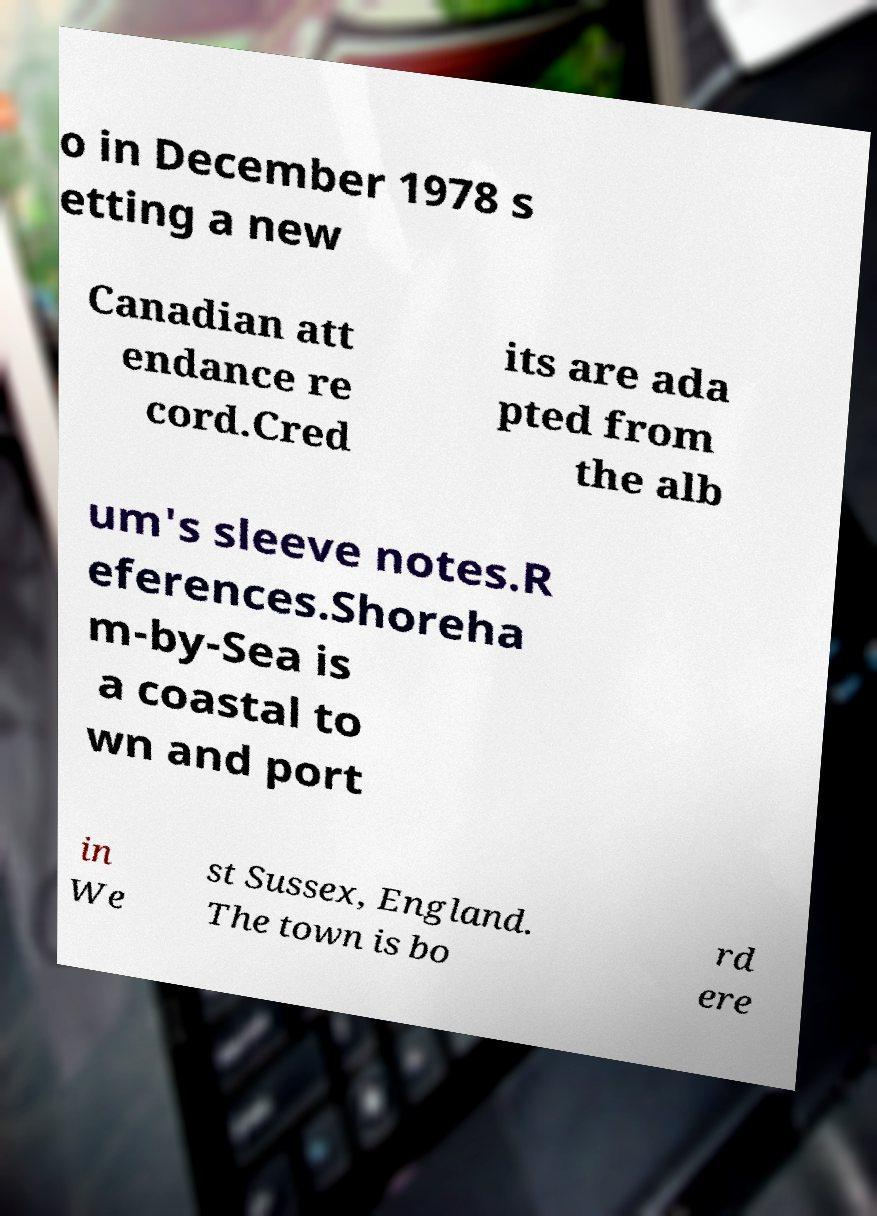Could you extract and type out the text from this image? o in December 1978 s etting a new Canadian att endance re cord.Cred its are ada pted from the alb um's sleeve notes.R eferences.Shoreha m-by-Sea is a coastal to wn and port in We st Sussex, England. The town is bo rd ere 